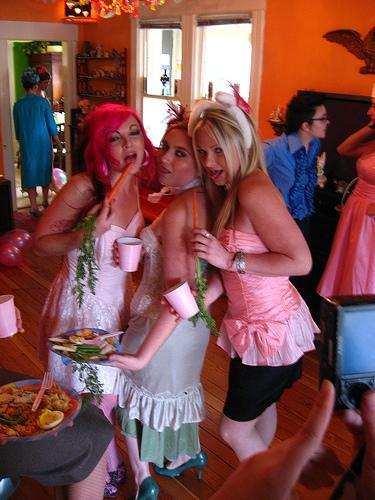Question: what is in the plate?
Choices:
A. Napkins.
B. Silverware.
C. Snacks.
D. Food.
Answer with the letter. Answer: D Question: why they are standing differently?
Choices:
A. They are different heights.
B. They are disabled.
C. They are tired.
D. For photo.
Answer with the letter. Answer: D 